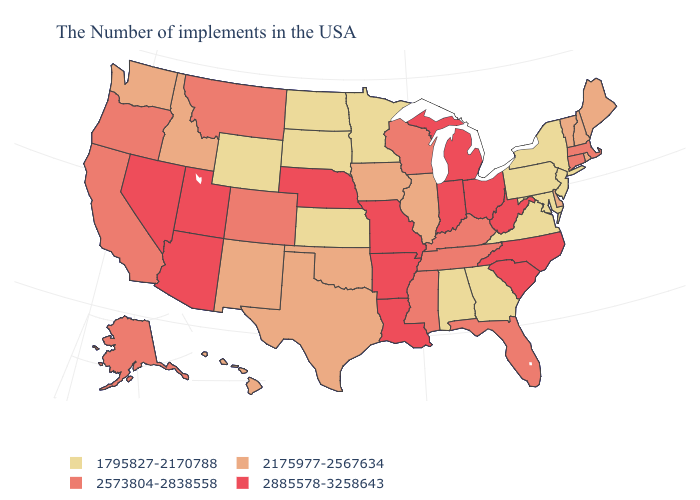Does Michigan have the highest value in the MidWest?
Concise answer only. Yes. Does Vermont have a higher value than New Mexico?
Give a very brief answer. No. How many symbols are there in the legend?
Short answer required. 4. Does Montana have the lowest value in the West?
Concise answer only. No. Name the states that have a value in the range 1795827-2170788?
Be succinct. New York, New Jersey, Maryland, Pennsylvania, Virginia, Georgia, Alabama, Minnesota, Kansas, South Dakota, North Dakota, Wyoming. Which states have the highest value in the USA?
Quick response, please. North Carolina, South Carolina, West Virginia, Ohio, Michigan, Indiana, Louisiana, Missouri, Arkansas, Nebraska, Utah, Arizona, Nevada. Does Kansas have the lowest value in the USA?
Answer briefly. Yes. Name the states that have a value in the range 2573804-2838558?
Concise answer only. Massachusetts, Connecticut, Florida, Kentucky, Tennessee, Wisconsin, Mississippi, Colorado, Montana, California, Oregon, Alaska. What is the value of Georgia?
Give a very brief answer. 1795827-2170788. Which states have the lowest value in the USA?
Keep it brief. New York, New Jersey, Maryland, Pennsylvania, Virginia, Georgia, Alabama, Minnesota, Kansas, South Dakota, North Dakota, Wyoming. What is the value of New Jersey?
Be succinct. 1795827-2170788. What is the lowest value in the USA?
Be succinct. 1795827-2170788. What is the lowest value in states that border Mississippi?
Write a very short answer. 1795827-2170788. Which states hav the highest value in the South?
Keep it brief. North Carolina, South Carolina, West Virginia, Louisiana, Arkansas. What is the value of Kansas?
Quick response, please. 1795827-2170788. 